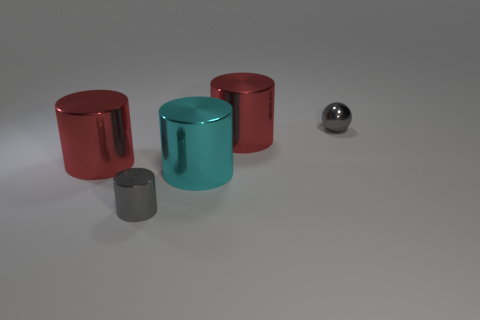Is the number of small cylinders greater than the number of big yellow cylinders?
Give a very brief answer. Yes. Is the color of the tiny metallic thing behind the cyan shiny cylinder the same as the small cylinder?
Provide a succinct answer. Yes. What is the color of the tiny cylinder?
Your answer should be very brief. Gray. There is a gray thing right of the cyan object; is there a big cylinder to the right of it?
Offer a terse response. No. What is the shape of the large object to the left of the gray shiny thing that is in front of the metallic ball?
Offer a terse response. Cylinder. Are there fewer large yellow metal blocks than cyan metallic things?
Your response must be concise. Yes. Does the tiny gray cylinder have the same material as the small gray ball?
Provide a succinct answer. Yes. There is a thing that is both behind the big cyan thing and to the left of the large cyan metallic thing; what is its color?
Provide a succinct answer. Red. Are there any gray metallic cylinders that have the same size as the cyan metal object?
Offer a very short reply. No. There is a gray shiny object that is right of the cylinder that is in front of the cyan object; how big is it?
Ensure brevity in your answer.  Small. 